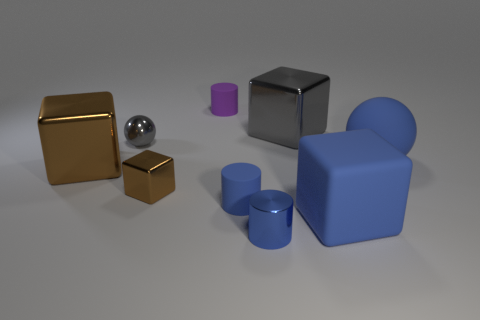Subtract all blue matte cylinders. How many cylinders are left? 2 Add 1 purple cylinders. How many objects exist? 10 Subtract all gray spheres. How many spheres are left? 1 Subtract 1 balls. How many balls are left? 1 Add 4 metal cylinders. How many metal cylinders exist? 5 Subtract 0 yellow cylinders. How many objects are left? 9 Subtract all cylinders. How many objects are left? 6 Subtract all green cylinders. Subtract all gray balls. How many cylinders are left? 3 Subtract all red cubes. How many blue balls are left? 1 Subtract all small blue matte balls. Subtract all big shiny blocks. How many objects are left? 7 